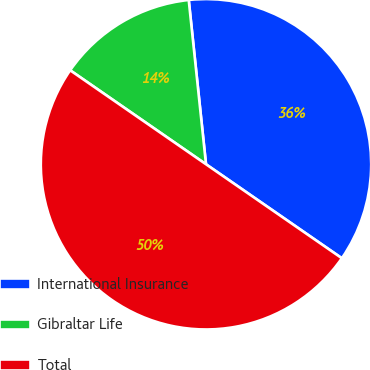Convert chart. <chart><loc_0><loc_0><loc_500><loc_500><pie_chart><fcel>International Insurance<fcel>Gibraltar Life<fcel>Total<nl><fcel>36.3%<fcel>13.7%<fcel>50.0%<nl></chart> 